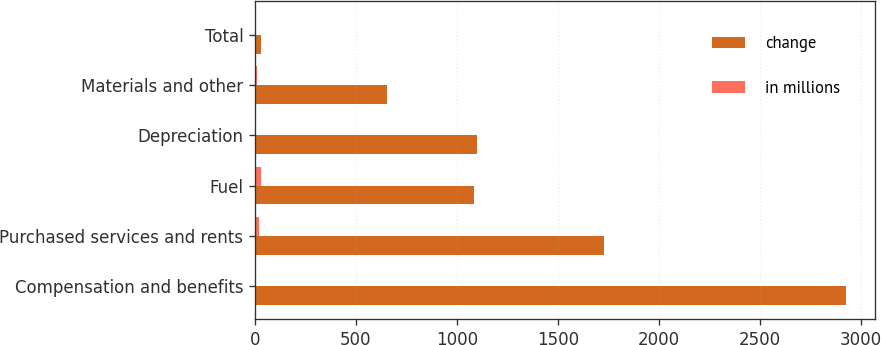<chart> <loc_0><loc_0><loc_500><loc_500><stacked_bar_chart><ecel><fcel>Compensation and benefits<fcel>Purchased services and rents<fcel>Fuel<fcel>Depreciation<fcel>Materials and other<fcel>Total<nl><fcel>change<fcel>2925<fcel>1730<fcel>1087<fcel>1102<fcel>655<fcel>29<nl><fcel>in millions<fcel>2<fcel>22<fcel>29<fcel>4<fcel>12<fcel>7<nl></chart> 